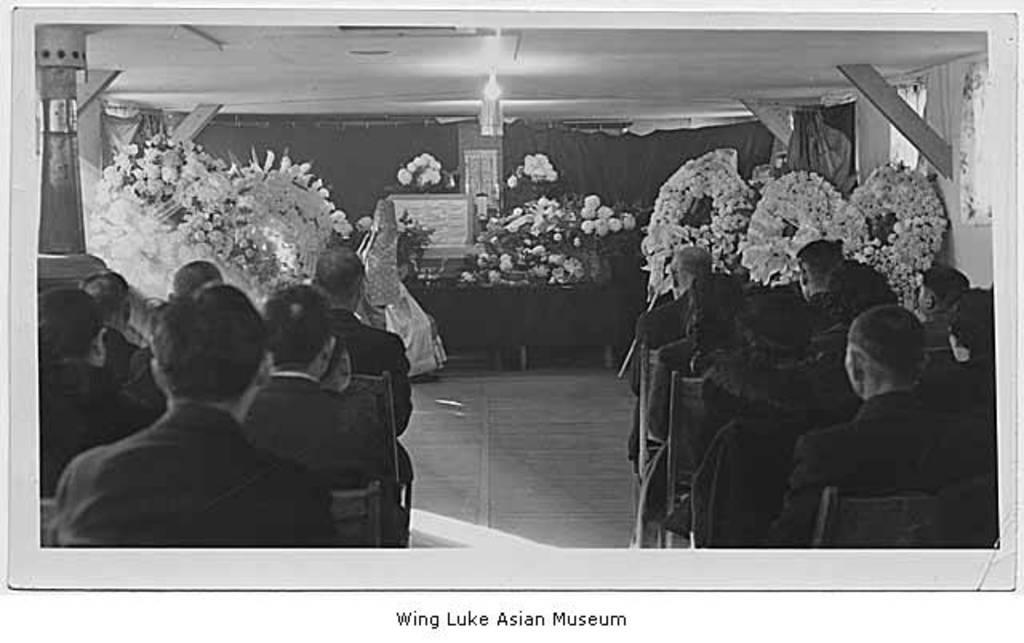Can you describe this image briefly? In this image, we can see a black and white photography. In this photograph, people are sitting on the benches. Background we can see decorative objects, curtains, people, few things and light. At the bottom of the image, we can see the text. 